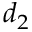Convert formula to latex. <formula><loc_0><loc_0><loc_500><loc_500>d _ { 2 }</formula> 